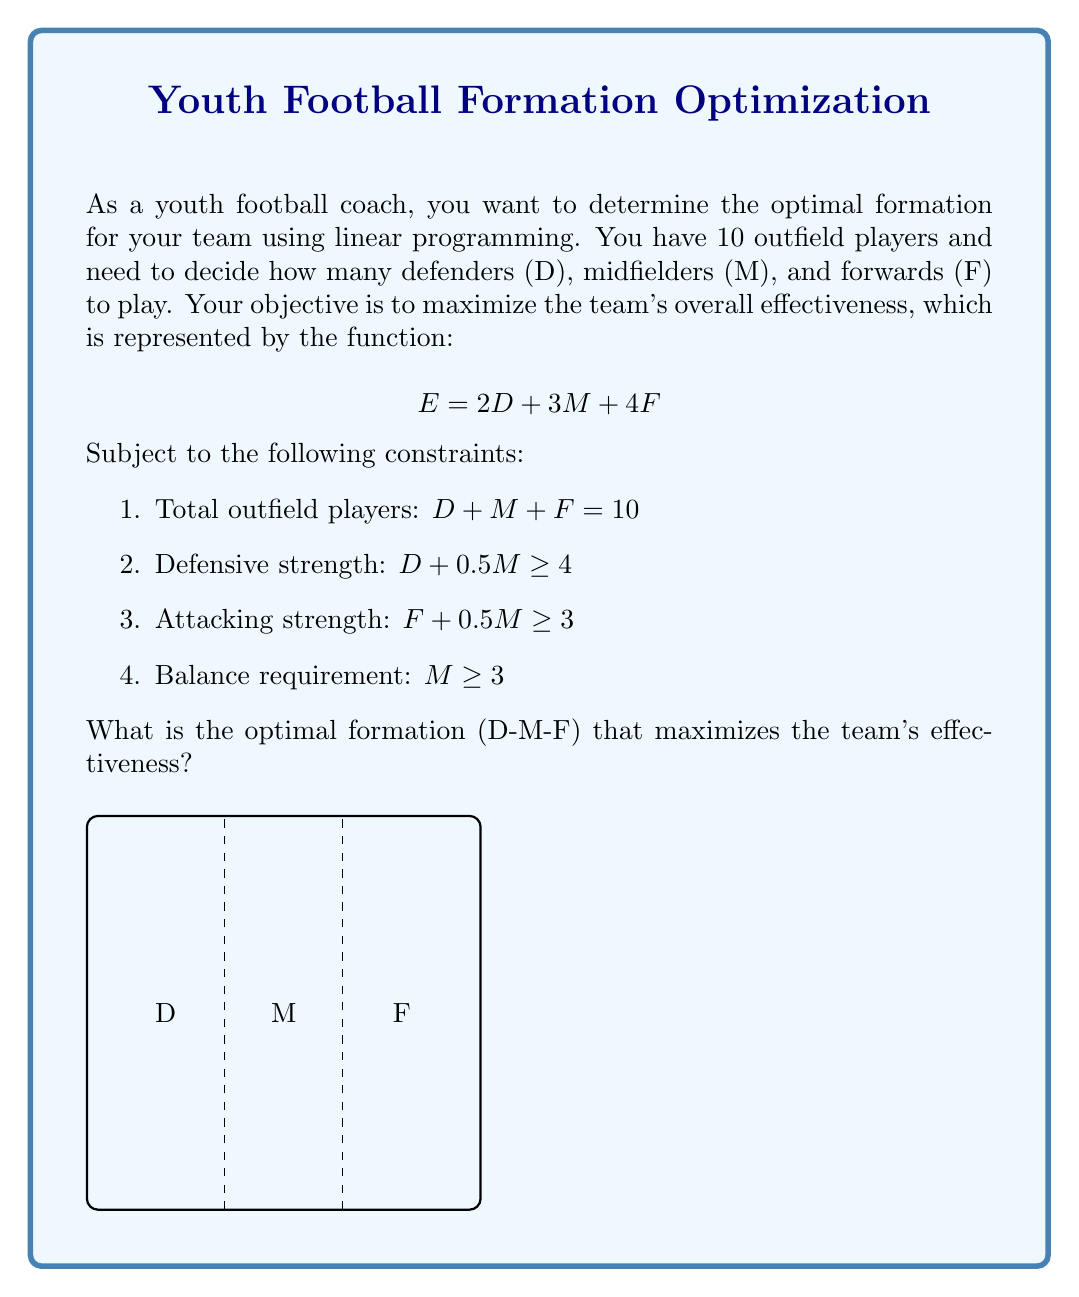Solve this math problem. Let's solve this step-by-step using the simplex method:

1) First, we need to convert the problem into standard form:
   Maximize: $E = 2D + 3M + 4F$
   Subject to:
   $D + M + F = 10$
   $-D - 0.5M + S_1 = -4$  (where $S_1$ is a slack variable)
   $-F - 0.5M + S_2 = -3$  (where $S_2$ is a slack variable)
   $-M + S_3 = -3$         (where $S_3$ is a slack variable)
   $D, M, F, S_1, S_2, S_3 \geq 0$

2) Set up the initial simplex tableau:

   $$
   \begin{array}{c|cccccc|c}
    & D & M & F & S_1 & S_2 & S_3 & RHS \\
   \hline
   S_1 & -1 & -0.5 & 0 & 1 & 0 & 0 & -4 \\
   S_2 & 0 & -0.5 & -1 & 0 & 1 & 0 & -3 \\
   S_3 & 0 & -1 & 0 & 0 & 0 & 1 & -3 \\
   \hline
   E & -2 & -3 & -4 & 0 & 0 & 0 & 0
   \end{array}
   $$

3) The most negative coefficient in the objective row is -4 (F), so F enters the basis. The limiting ratio is min(3/1, 3/0.5) = 3, so S_2 leaves the basis.

4) After pivoting, we get:

   $$
   \begin{array}{c|cccccc|c}
    & D & M & F & S_1 & S_2 & S_3 & RHS \\
   \hline
   S_1 & -1 & -0.5 & 0 & 1 & 0 & 0 & -4 \\
   F & 0 & 0.5 & 1 & 0 & -1 & 0 & 3 \\
   S_3 & 0 & -1 & 0 & 0 & 0 & 1 & -3 \\
   \hline
   E & -2 & -1 & 0 & 0 & 4 & 0 & 12
   \end{array}
   $$

5) Now the most negative coefficient is -2 (D), so D enters the basis. The limiting ratio is 4/1 = 4, so S_1 leaves.

6) After pivoting again:

   $$
   \begin{array}{c|cccccc|c}
    & D & M & F & S_1 & S_2 & S_3 & RHS \\
   \hline
   D & 1 & 0.5 & 0 & -1 & 0 & 0 & 4 \\
   F & 0 & 0.5 & 1 & 0 & -1 & 0 & 3 \\
   S_3 & 0 & -1 & 0 & 0 & 0 & 1 & -3 \\
   \hline
   E & 0 & 0 & 0 & 2 & 4 & 0 & 20
   \end{array}
   $$

7) There are no more negative coefficients in the objective row, so we've reached the optimal solution.

8) Reading from the tableau:
   $D = 4$
   $F = 3$
   $M = 10 - D - F = 10 - 4 - 3 = 3$

Therefore, the optimal formation is 4-3-3 (D-M-F).
Answer: 4-3-3 